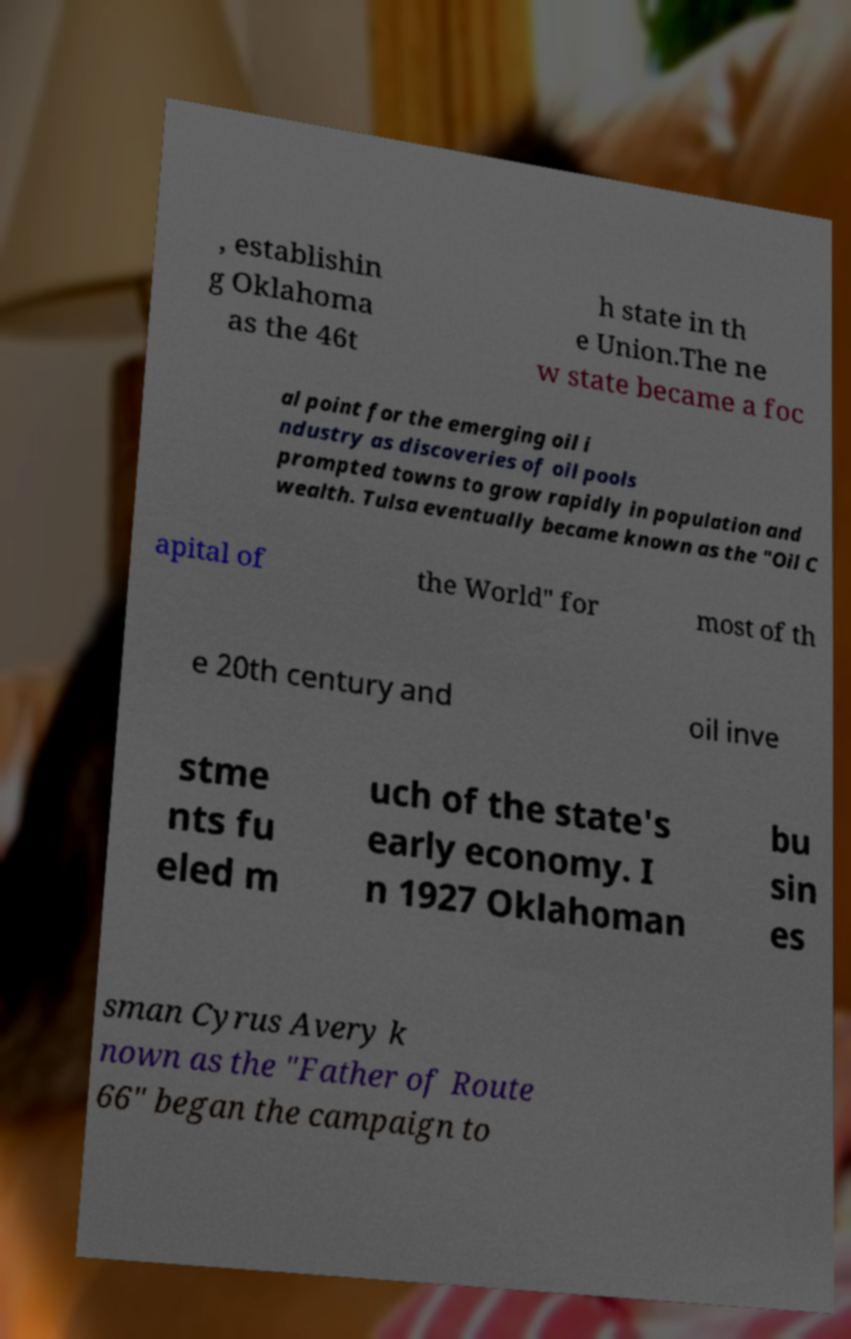Could you extract and type out the text from this image? , establishin g Oklahoma as the 46t h state in th e Union.The ne w state became a foc al point for the emerging oil i ndustry as discoveries of oil pools prompted towns to grow rapidly in population and wealth. Tulsa eventually became known as the "Oil C apital of the World" for most of th e 20th century and oil inve stme nts fu eled m uch of the state's early economy. I n 1927 Oklahoman bu sin es sman Cyrus Avery k nown as the "Father of Route 66" began the campaign to 